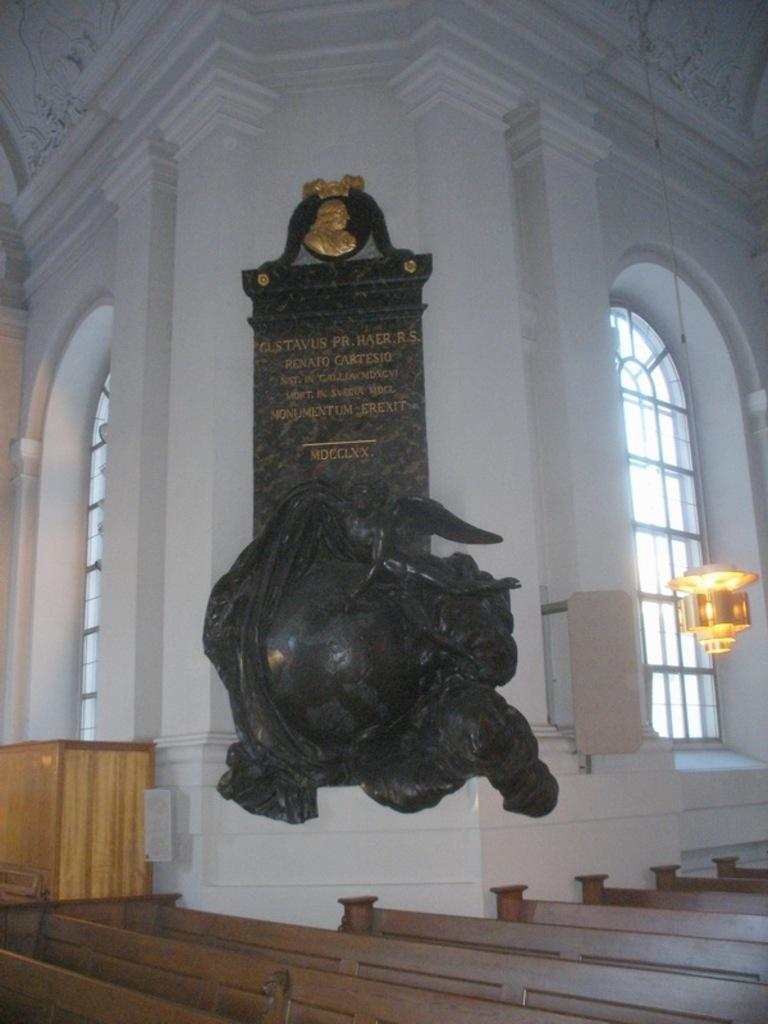What is written or displayed on the board in the image? There is a board with text in the image. What type of object is attached to the wall in the image? There is a statue on the wall in the image. What kind of container is present in the image? There is a wooden box in the image. What type of seating is available in the image? There are benches in the image. What source of illumination is visible in the image? There is a light in the image. What type of transparent material is used for the windows in the image? There are glass windows in the image. How many cacti can be seen in the garden area of the image? There is no garden or cacti present in the image. What type of weapon is mounted on the wall next to the statue in the image? There is no weapon or cannon present in the image. 